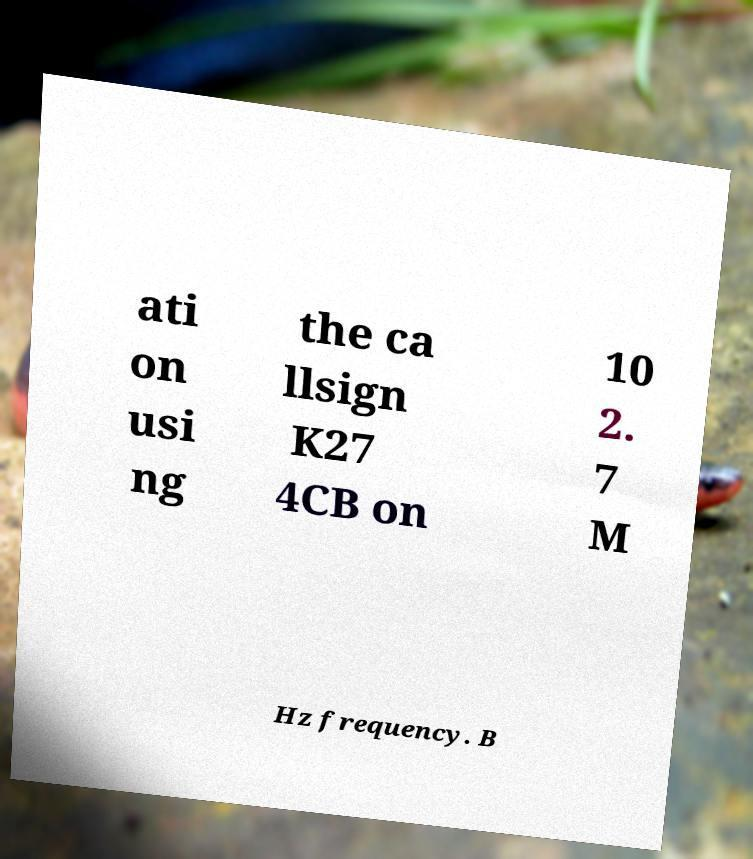Can you read and provide the text displayed in the image?This photo seems to have some interesting text. Can you extract and type it out for me? ati on usi ng the ca llsign K27 4CB on 10 2. 7 M Hz frequency. B 